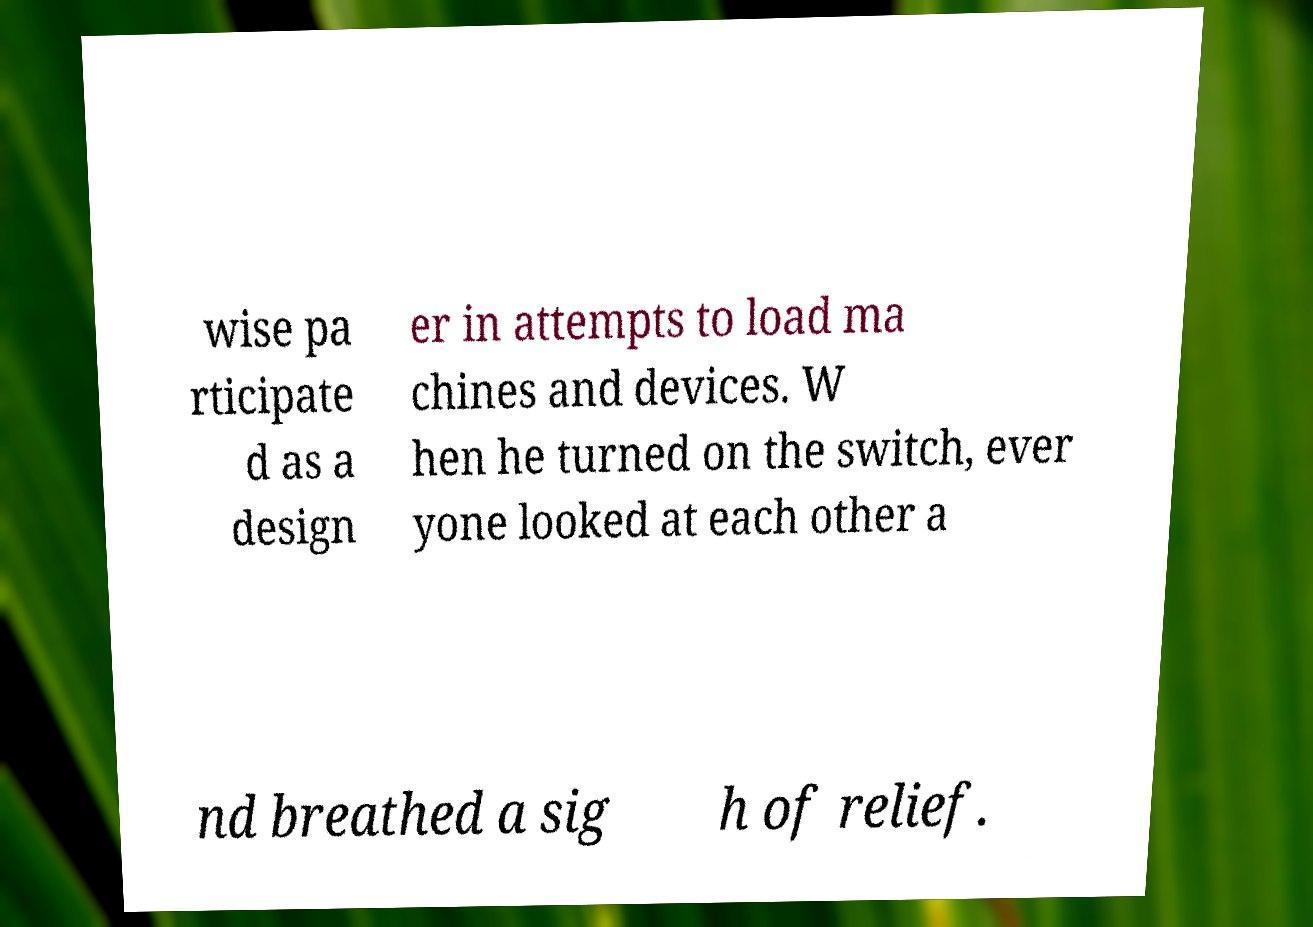I need the written content from this picture converted into text. Can you do that? wise pa rticipate d as a design er in attempts to load ma chines and devices. W hen he turned on the switch, ever yone looked at each other a nd breathed a sig h of relief. 